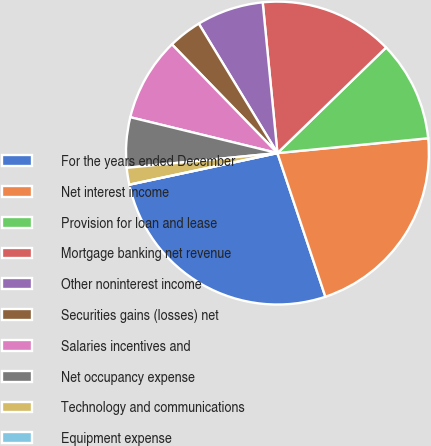Convert chart. <chart><loc_0><loc_0><loc_500><loc_500><pie_chart><fcel>For the years ended December<fcel>Net interest income<fcel>Provision for loan and lease<fcel>Mortgage banking net revenue<fcel>Other noninterest income<fcel>Securities gains (losses) net<fcel>Salaries incentives and<fcel>Net occupancy expense<fcel>Technology and communications<fcel>Equipment expense<nl><fcel>26.78%<fcel>21.43%<fcel>10.71%<fcel>14.28%<fcel>7.14%<fcel>3.57%<fcel>8.93%<fcel>5.36%<fcel>1.79%<fcel>0.0%<nl></chart> 